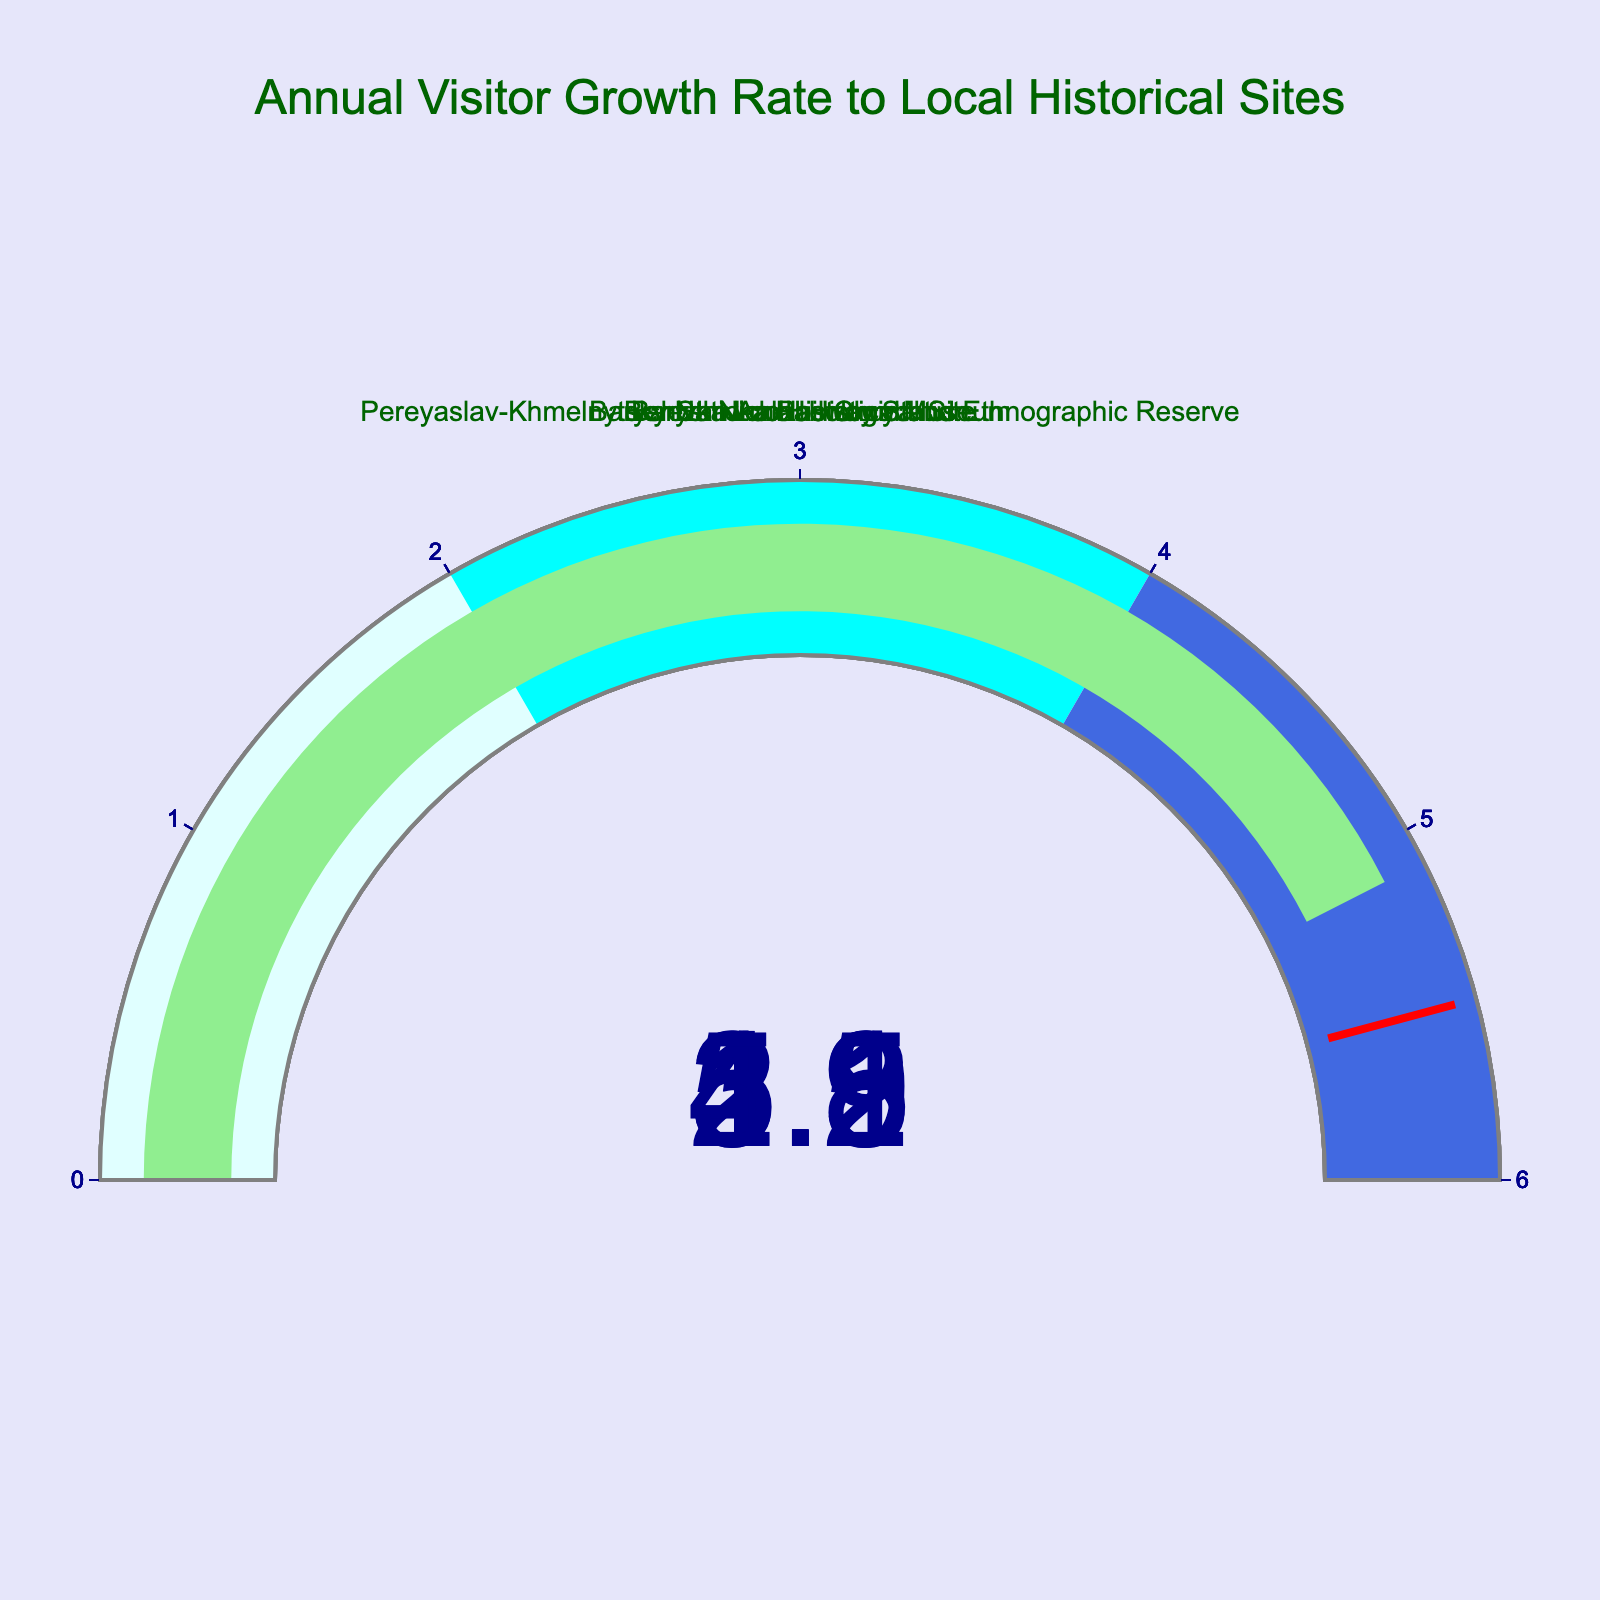How many historical sites are displayed on the gauge chart? The chart displays a separate gauge for each historical site listed. Counting the names shown, there are five sites.
Answer: 5 Which site has the highest annual visitor growth rate? The gauge corresponding to the Pereyaslav-Khmelnytsky National Historical and Ethnographic Reserve shows the highest value at 5.1.
Answer: Pereyaslav-Khmelnytsky National Historical and Ethnographic Reserve What's the difference in growth rate between the Pereyaslav-Khmelnytsky National Historical and Ethnographic Reserve and the Baryshivka Railway Station? Subtract the growth rate of Baryshivka Railway Station (1.9) from the growth rate of Pereyaslav-Khmelnytsky National Historical and Ethnographic Reserve (5.1), resulting in 5.1 - 1.9 = 3.2.
Answer: 3.2 Is there any site with a growth rate below 2.0? Inspect all the gauges, and only the Baryshivka Railway Station shows a growth rate (1.9) below 2.0.
Answer: Yes Which site has the second highest growth rate and what is its value? The Berezan Archaeological Site has the second highest growth rate among the displayed sites, with a value of 4.2.
Answer: Berezan Archaeological Site, 4.2 What colors are used on the gauge chart? The gauge chart uses several colors including: lightcyan (for 0-2 range), cyan (for 2-4 range), royalblue (for 4-6 range), lightgreen (for the bar), darkblue (for ticks), and red (for threshold line).
Answer: lightcyan, cyan, royalblue, lightgreen, darkblue, red What's the average growth rate of all the historical sites? Sum the growth rates of all sites (3.5 + 2.8 + 4.2 + 1.9 + 5.1 = 17.5) and divide by the number of sites (5), resulting in an average of 17.5/5 = 3.5.
Answer: 3.5 Are there more sites with a growth rate above or below 3.5? There are two sites with growth rates below 3.5 (St. Nicholas Church - 2.8 and Baryshivka Railway Station - 1.9) and three sites with growth rates above 3.5 (Baryshivka Local History Museum - 3.5, Berezan Archaeological Site - 4.2, Pereyaslav-Khmelnytsky National Historical and Ethnographic Reserve - 5.1). Thus, there are more sites with a growth rate above 3.5.
Answer: Above What is the range of the growth rates shown in the chart? The lowest growth rate displayed is 1.9 (Baryshivka Railway Station), and the highest is 5.1 (Pereyaslav-Khmelnytsky National Historical and Ethnographic Reserve); hence, the range is 5.1 - 1.9 = 3.2.
Answer: 3.2 